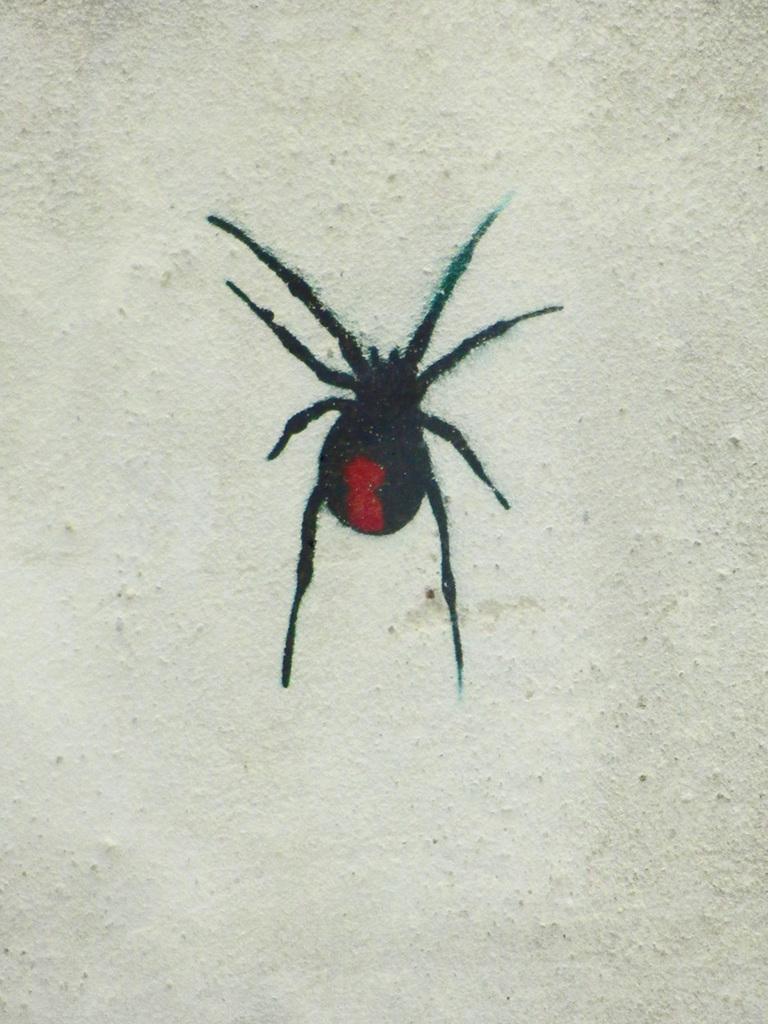Can you describe this image briefly? In this image there is an insect on the white color wall. 